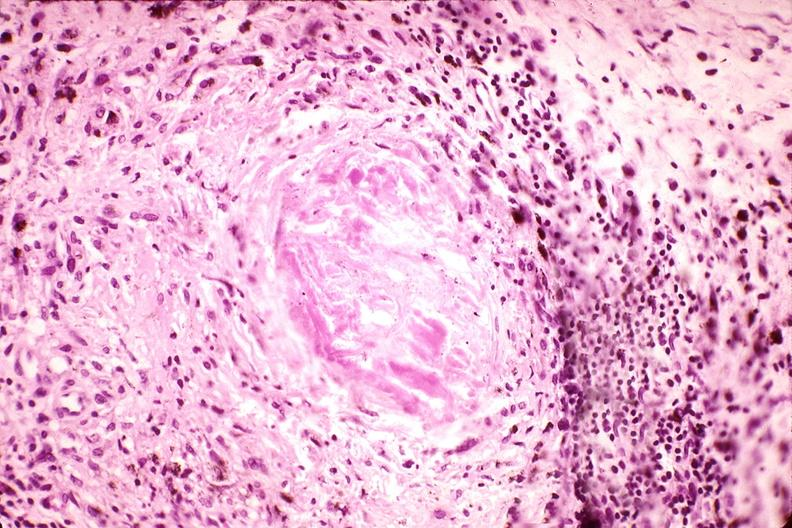what does this image show?
Answer the question using a single word or phrase. Synovium 